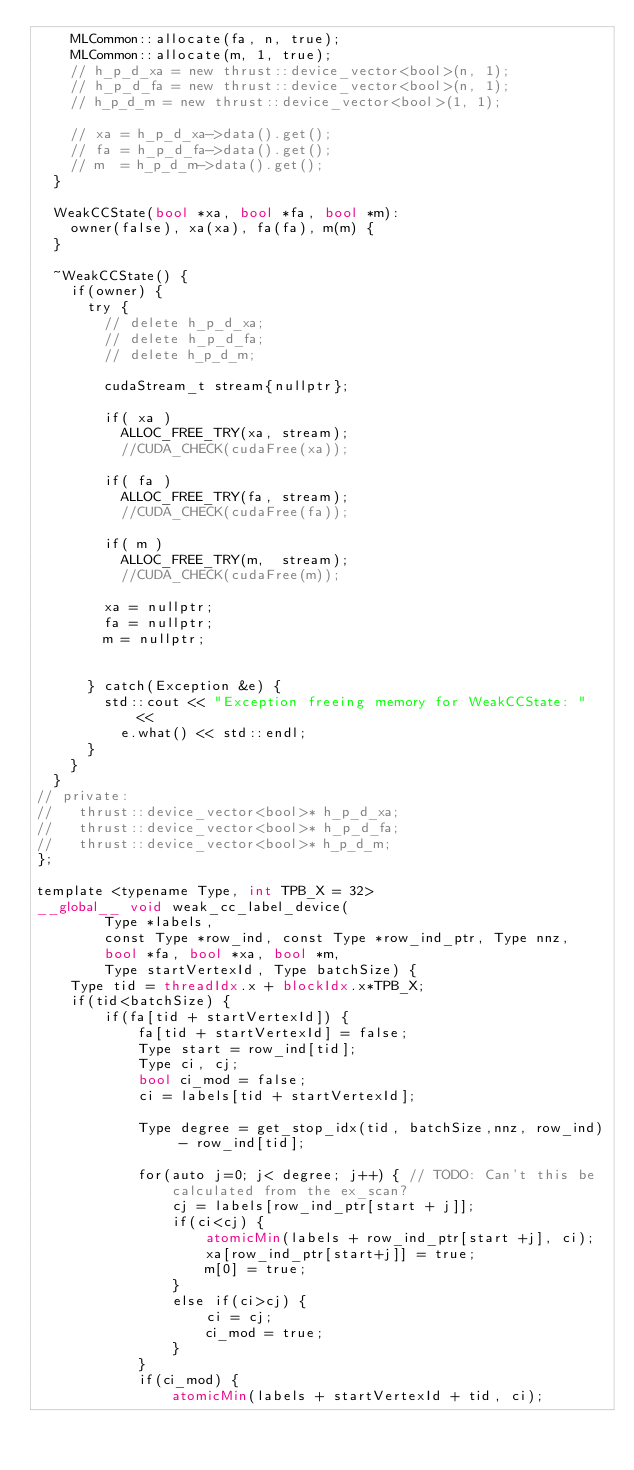Convert code to text. <code><loc_0><loc_0><loc_500><loc_500><_Cuda_>    MLCommon::allocate(fa, n, true);
    MLCommon::allocate(m, 1, true);
    // h_p_d_xa = new thrust::device_vector<bool>(n, 1);
    // h_p_d_fa = new thrust::device_vector<bool>(n, 1);
    // h_p_d_m = new thrust::device_vector<bool>(1, 1);

    // xa = h_p_d_xa->data().get();
    // fa = h_p_d_fa->data().get();
    // m  = h_p_d_m->data().get();
  }

  WeakCCState(bool *xa, bool *fa, bool *m):
    owner(false), xa(xa), fa(fa), m(m) {
  }

  ~WeakCCState() {
    if(owner) {
      try {
        // delete h_p_d_xa;
        // delete h_p_d_fa;
        // delete h_p_d_m;
               
        cudaStream_t stream{nullptr};
        
        if( xa )
          ALLOC_FREE_TRY(xa, stream);
          //CUDA_CHECK(cudaFree(xa));

        if( fa )
          ALLOC_FREE_TRY(fa, stream);
          //CUDA_CHECK(cudaFree(fa));

        if( m )
          ALLOC_FREE_TRY(m,  stream);
          //CUDA_CHECK(cudaFree(m));

        xa = nullptr;
        fa = nullptr;
        m = nullptr;
          
        
      } catch(Exception &e) {
        std::cout << "Exception freeing memory for WeakCCState: " <<
          e.what() << std::endl;
      }
    }
  }
// private:
//   thrust::device_vector<bool>* h_p_d_xa;
//   thrust::device_vector<bool>* h_p_d_fa;
//   thrust::device_vector<bool>* h_p_d_m;
};

template <typename Type, int TPB_X = 32>
__global__ void weak_cc_label_device(
        Type *labels,
        const Type *row_ind, const Type *row_ind_ptr, Type nnz,
        bool *fa, bool *xa, bool *m,
        Type startVertexId, Type batchSize) {
    Type tid = threadIdx.x + blockIdx.x*TPB_X;
    if(tid<batchSize) {
        if(fa[tid + startVertexId]) {
            fa[tid + startVertexId] = false;
            Type start = row_ind[tid];
            Type ci, cj;
            bool ci_mod = false;
            ci = labels[tid + startVertexId];

            Type degree = get_stop_idx(tid, batchSize,nnz, row_ind) - row_ind[tid];

            for(auto j=0; j< degree; j++) { // TODO: Can't this be calculated from the ex_scan?
                cj = labels[row_ind_ptr[start + j]];
                if(ci<cj) {
                    atomicMin(labels + row_ind_ptr[start +j], ci);
                    xa[row_ind_ptr[start+j]] = true;
                    m[0] = true;
                }
                else if(ci>cj) {
                    ci = cj;
                    ci_mod = true;
                }
            }
            if(ci_mod) {
                atomicMin(labels + startVertexId + tid, ci);</code> 